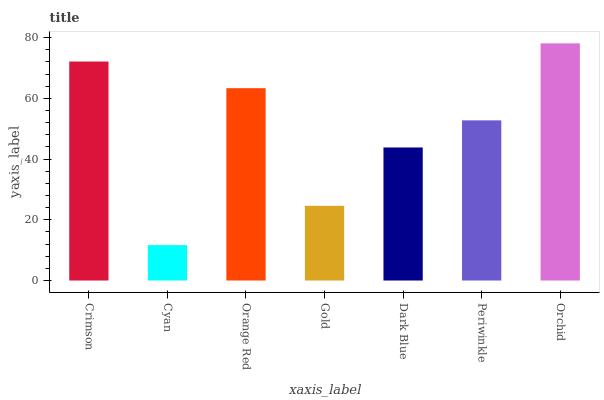Is Cyan the minimum?
Answer yes or no. Yes. Is Orchid the maximum?
Answer yes or no. Yes. Is Orange Red the minimum?
Answer yes or no. No. Is Orange Red the maximum?
Answer yes or no. No. Is Orange Red greater than Cyan?
Answer yes or no. Yes. Is Cyan less than Orange Red?
Answer yes or no. Yes. Is Cyan greater than Orange Red?
Answer yes or no. No. Is Orange Red less than Cyan?
Answer yes or no. No. Is Periwinkle the high median?
Answer yes or no. Yes. Is Periwinkle the low median?
Answer yes or no. Yes. Is Crimson the high median?
Answer yes or no. No. Is Dark Blue the low median?
Answer yes or no. No. 